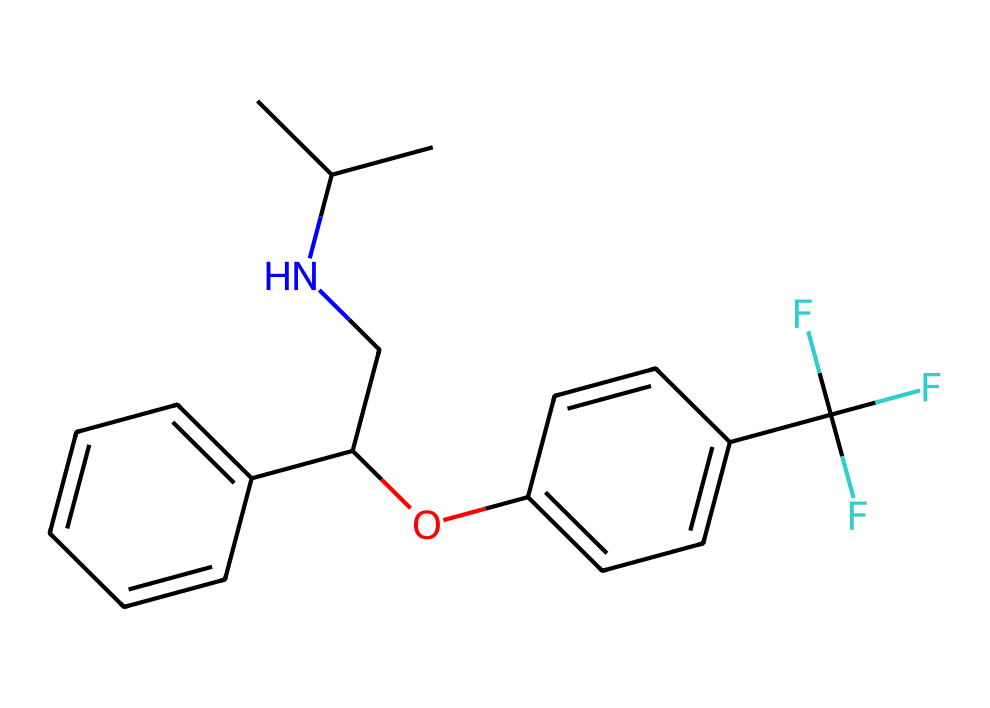What is the name of this chemical? The provided SMILES representation corresponds to fluoxetine, which is commonly known as Prozac. The specific structure includes various functional groups typical of this drug.
Answer: fluoxetine How many carbon atoms are present in this molecule? Analyzing the SMILES representation reveals several carbon atoms in both the alkane and aromatic rings. Counting them gives a total of 17 carbon atoms.
Answer: 17 What functional group is mainly present in this molecule? The presence of the hydroxyl group (-OH) alongside the carbon chain indicates that fluoxetine has a phenolic functional group. This specifies its interaction capabilities in the brain.
Answer: phenolic How many fluorine atoms are in this structure? From the SMILES representation, one can identify that there are three fluorine atoms attached to the carbon in the structure, which is indicated explicitly in the SMILES notation.
Answer: 3 What is the primary action of fluoxetine in relation to serotonin receptors? Fluoxetine primarily acts as a selective serotonin reuptake inhibitor (SSRI), blocking the reabsorption of serotonin in the brain to enhance its mood-lifting effects.
Answer: SSRI How does the presence of the nitrogen atom affect the drug’s activity? The nitrogen atom in the side chain of fluoxetine is crucial as it contributes to the drug's ability to interact specifically with serotonin receptors, influencing its pharmacological activity.
Answer: increases activity What role does the aromatic ring play in this chemical's effectiveness? The aromatic rings in fluoxetine enhance its binding affinity to serotonin receptors, making the molecule more effective in altering serotonin levels and resulting in its antidepressant properties.
Answer: binding affinity 